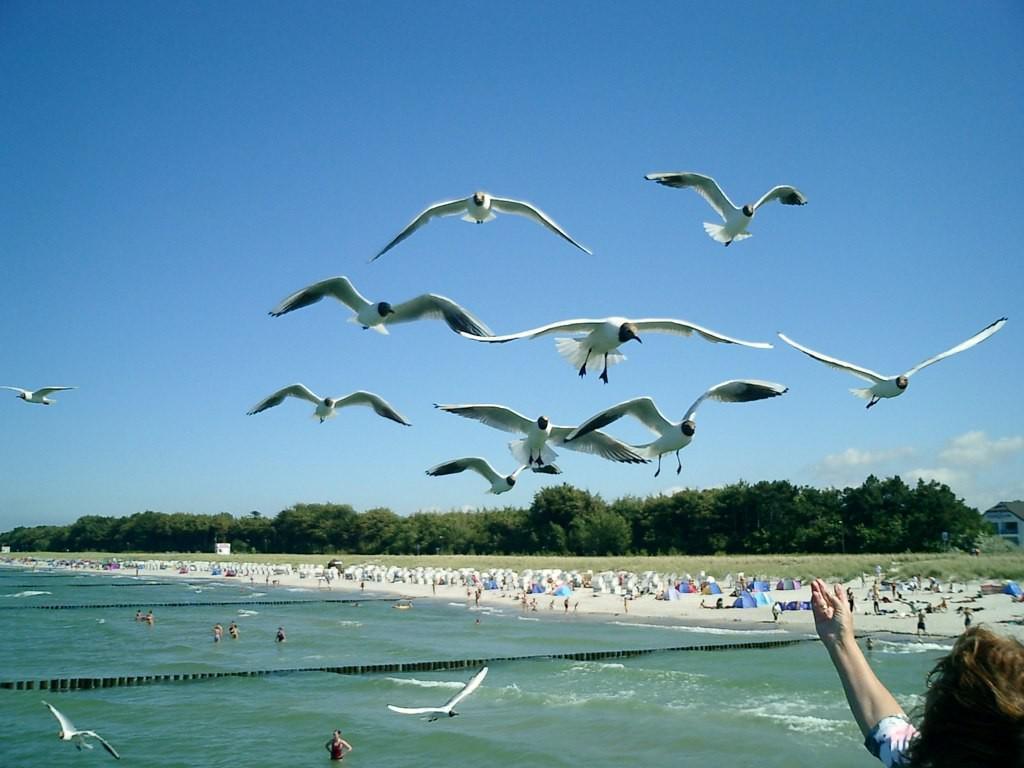Could you give a brief overview of what you see in this image? These are boats and trees, this is water and a sky. 